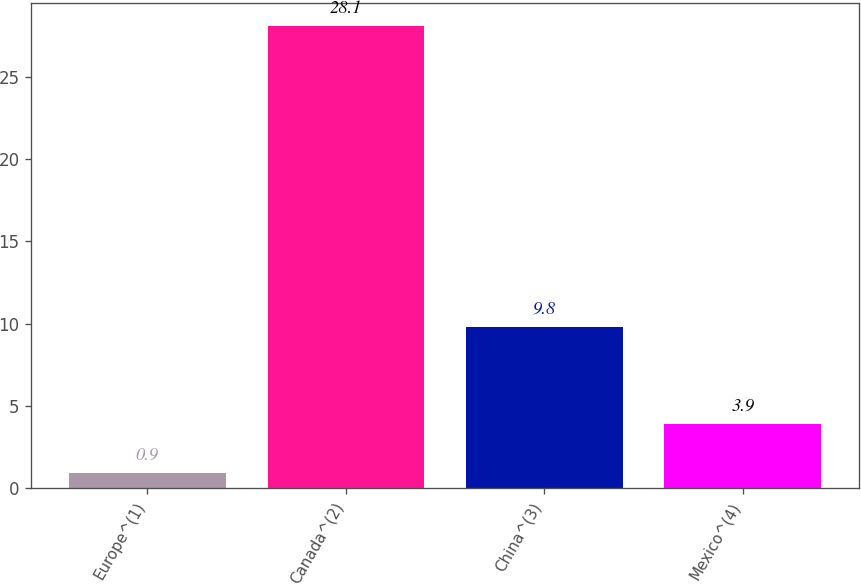Convert chart to OTSL. <chart><loc_0><loc_0><loc_500><loc_500><bar_chart><fcel>Europe^(1)<fcel>Canada^(2)<fcel>China^(3)<fcel>Mexico^(4)<nl><fcel>0.9<fcel>28.1<fcel>9.8<fcel>3.9<nl></chart> 